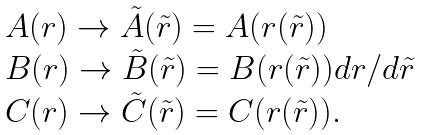<formula> <loc_0><loc_0><loc_500><loc_500>\begin{array} { l r } A ( r ) \rightarrow \tilde { A } ( \tilde { r } ) = A ( r ( \tilde { r } ) ) \\ B ( r ) \rightarrow \tilde { B } ( \tilde { r } ) = B ( r ( \tilde { r } ) ) d r / d \tilde { r } \\ C ( r ) \rightarrow \tilde { C } ( \tilde { r } ) = C ( r ( \tilde { r } ) ) . \end{array}</formula> 